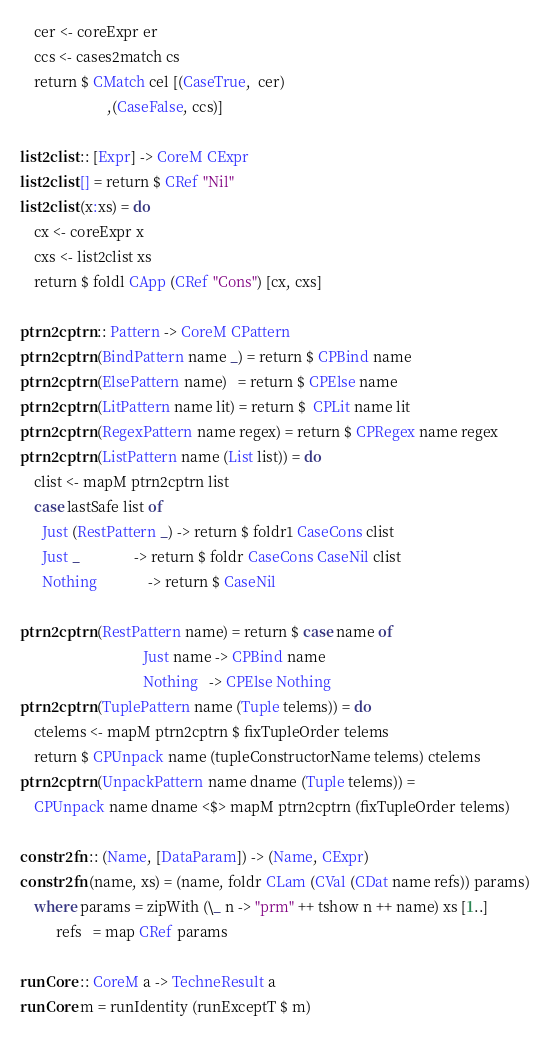<code> <loc_0><loc_0><loc_500><loc_500><_Haskell_>    cer <- coreExpr er
    ccs <- cases2match cs
    return $ CMatch cel [(CaseTrue,  cer)
                        ,(CaseFalse, ccs)]

list2clist :: [Expr] -> CoreM CExpr
list2clist [] = return $ CRef "Nil"
list2clist (x:xs) = do
    cx <- coreExpr x
    cxs <- list2clist xs
    return $ foldl CApp (CRef "Cons") [cx, cxs]

ptrn2cptrn :: Pattern -> CoreM CPattern
ptrn2cptrn (BindPattern name _) = return $ CPBind name
ptrn2cptrn (ElsePattern name)   = return $ CPElse name
ptrn2cptrn (LitPattern name lit) = return $  CPLit name lit
ptrn2cptrn (RegexPattern name regex) = return $ CPRegex name regex
ptrn2cptrn (ListPattern name (List list)) = do
    clist <- mapM ptrn2cptrn list
    case lastSafe list of
      Just (RestPattern _) -> return $ foldr1 CaseCons clist
      Just _               -> return $ foldr CaseCons CaseNil clist
      Nothing              -> return $ CaseNil

ptrn2cptrn (RestPattern name) = return $ case name of
                                  Just name -> CPBind name
                                  Nothing   -> CPElse Nothing
ptrn2cptrn (TuplePattern name (Tuple telems)) = do
    ctelems <- mapM ptrn2cptrn $ fixTupleOrder telems
    return $ CPUnpack name (tupleConstructorName telems) ctelems
ptrn2cptrn (UnpackPattern name dname (Tuple telems)) =
    CPUnpack name dname <$> mapM ptrn2cptrn (fixTupleOrder telems)

constr2fn :: (Name, [DataParam]) -> (Name, CExpr)
constr2fn (name, xs) = (name, foldr CLam (CVal (CDat name refs)) params)
    where params = zipWith (\_ n -> "prm" ++ tshow n ++ name) xs [1..]
          refs   = map CRef params

runCore :: CoreM a -> TechneResult a
runCore m = runIdentity (runExceptT $ m)
</code> 